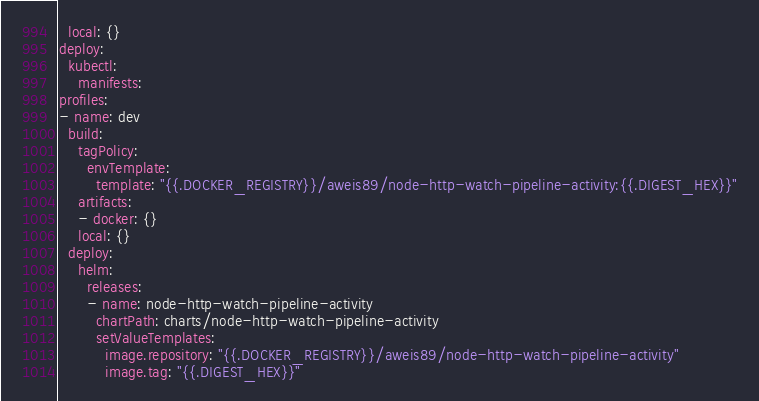Convert code to text. <code><loc_0><loc_0><loc_500><loc_500><_YAML_>  local: {}
deploy:
  kubectl:
    manifests:
profiles:
- name: dev
  build:
    tagPolicy:
      envTemplate:
        template: "{{.DOCKER_REGISTRY}}/aweis89/node-http-watch-pipeline-activity:{{.DIGEST_HEX}}"
    artifacts:
    - docker: {}
    local: {}
  deploy:
    helm:
      releases:
      - name: node-http-watch-pipeline-activity
        chartPath: charts/node-http-watch-pipeline-activity
        setValueTemplates:
          image.repository: "{{.DOCKER_REGISTRY}}/aweis89/node-http-watch-pipeline-activity"
          image.tag: "{{.DIGEST_HEX}}"
</code> 